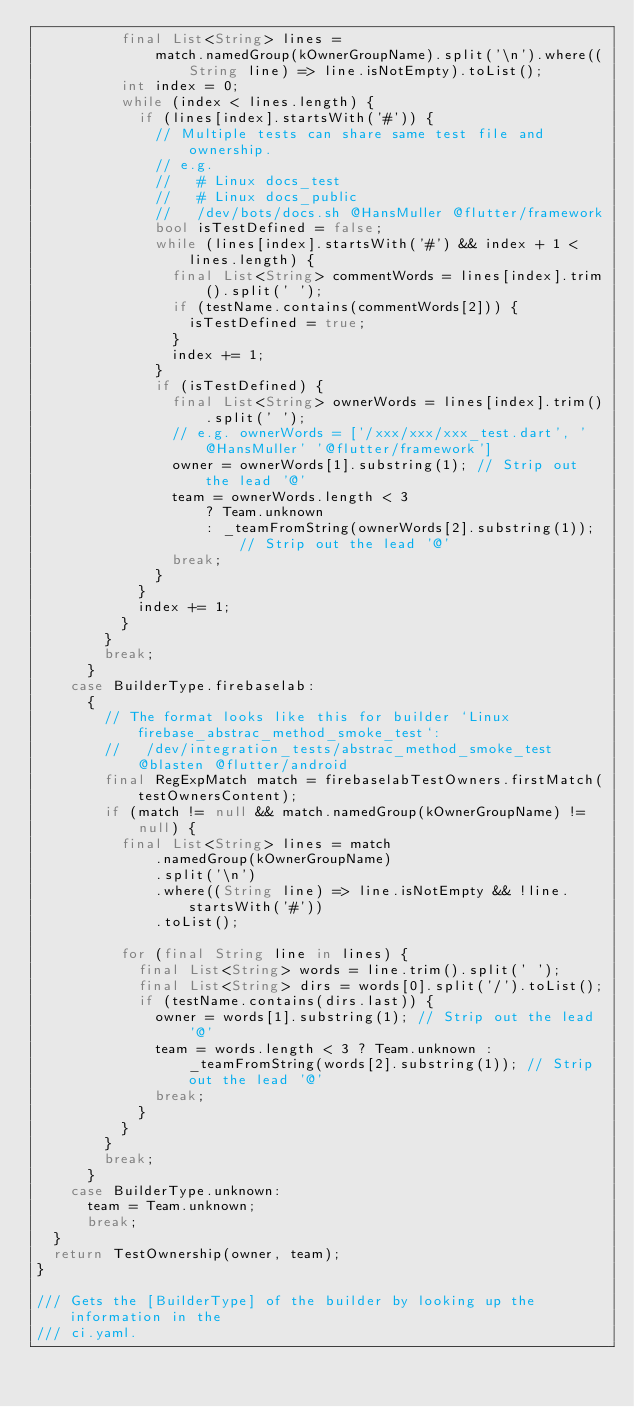<code> <loc_0><loc_0><loc_500><loc_500><_Dart_>          final List<String> lines =
              match.namedGroup(kOwnerGroupName).split('\n').where((String line) => line.isNotEmpty).toList();
          int index = 0;
          while (index < lines.length) {
            if (lines[index].startsWith('#')) {
              // Multiple tests can share same test file and ownership.
              // e.g.
              //   # Linux docs_test
              //   # Linux docs_public
              //   /dev/bots/docs.sh @HansMuller @flutter/framework
              bool isTestDefined = false;
              while (lines[index].startsWith('#') && index + 1 < lines.length) {
                final List<String> commentWords = lines[index].trim().split(' ');
                if (testName.contains(commentWords[2])) {
                  isTestDefined = true;
                }
                index += 1;
              }
              if (isTestDefined) {
                final List<String> ownerWords = lines[index].trim().split(' ');
                // e.g. ownerWords = ['/xxx/xxx/xxx_test.dart', '@HansMuller' '@flutter/framework']
                owner = ownerWords[1].substring(1); // Strip out the lead '@'
                team = ownerWords.length < 3
                    ? Team.unknown
                    : _teamFromString(ownerWords[2].substring(1)); // Strip out the lead '@'
                break;
              }
            }
            index += 1;
          }
        }
        break;
      }
    case BuilderType.firebaselab:
      {
        // The format looks like this for builder `Linux firebase_abstrac_method_smoke_test`:
        //   /dev/integration_tests/abstrac_method_smoke_test @blasten @flutter/android
        final RegExpMatch match = firebaselabTestOwners.firstMatch(testOwnersContent);
        if (match != null && match.namedGroup(kOwnerGroupName) != null) {
          final List<String> lines = match
              .namedGroup(kOwnerGroupName)
              .split('\n')
              .where((String line) => line.isNotEmpty && !line.startsWith('#'))
              .toList();

          for (final String line in lines) {
            final List<String> words = line.trim().split(' ');
            final List<String> dirs = words[0].split('/').toList();
            if (testName.contains(dirs.last)) {
              owner = words[1].substring(1); // Strip out the lead '@'
              team = words.length < 3 ? Team.unknown : _teamFromString(words[2].substring(1)); // Strip out the lead '@'
              break;
            }
          }
        }
        break;
      }
    case BuilderType.unknown:
      team = Team.unknown;
      break;
  }
  return TestOwnership(owner, team);
}

/// Gets the [BuilderType] of the builder by looking up the information in the
/// ci.yaml.</code> 